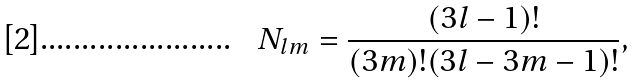Convert formula to latex. <formula><loc_0><loc_0><loc_500><loc_500>N _ { l m } = \frac { ( 3 l - 1 ) ! } { ( 3 m ) ! ( 3 l - 3 m - 1 ) ! } ,</formula> 